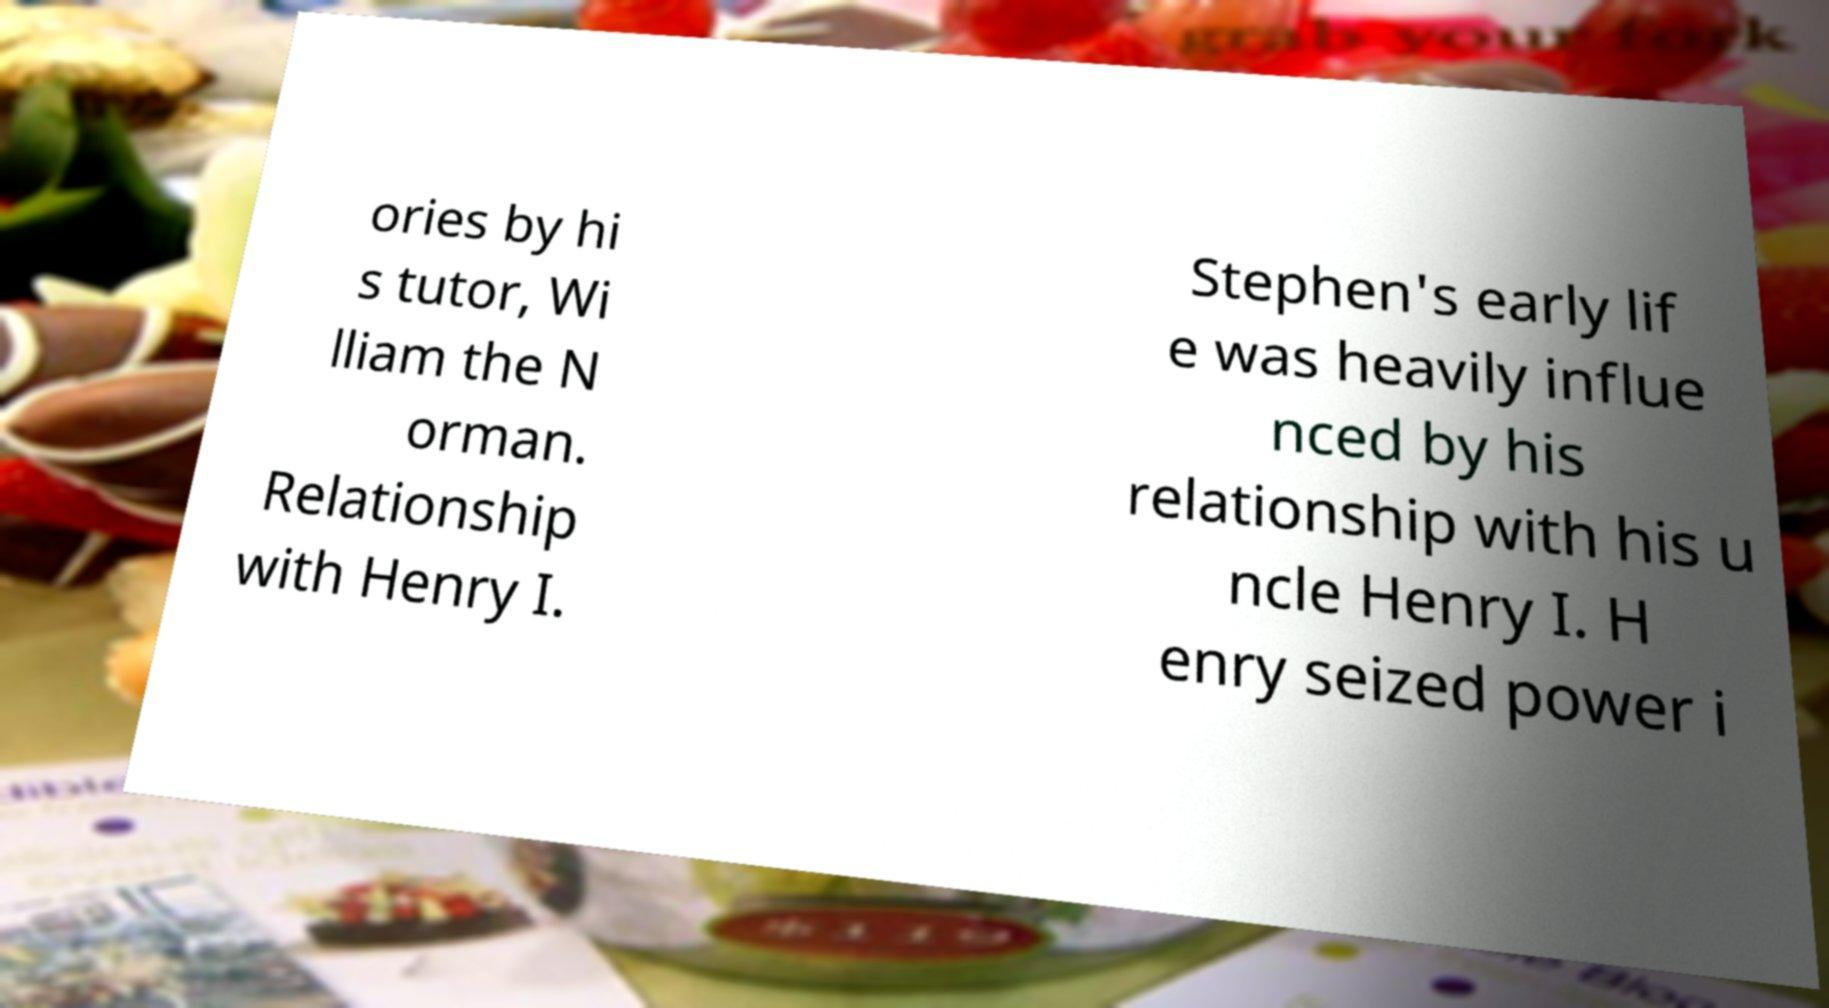There's text embedded in this image that I need extracted. Can you transcribe it verbatim? ories by hi s tutor, Wi lliam the N orman. Relationship with Henry I. Stephen's early lif e was heavily influe nced by his relationship with his u ncle Henry I. H enry seized power i 